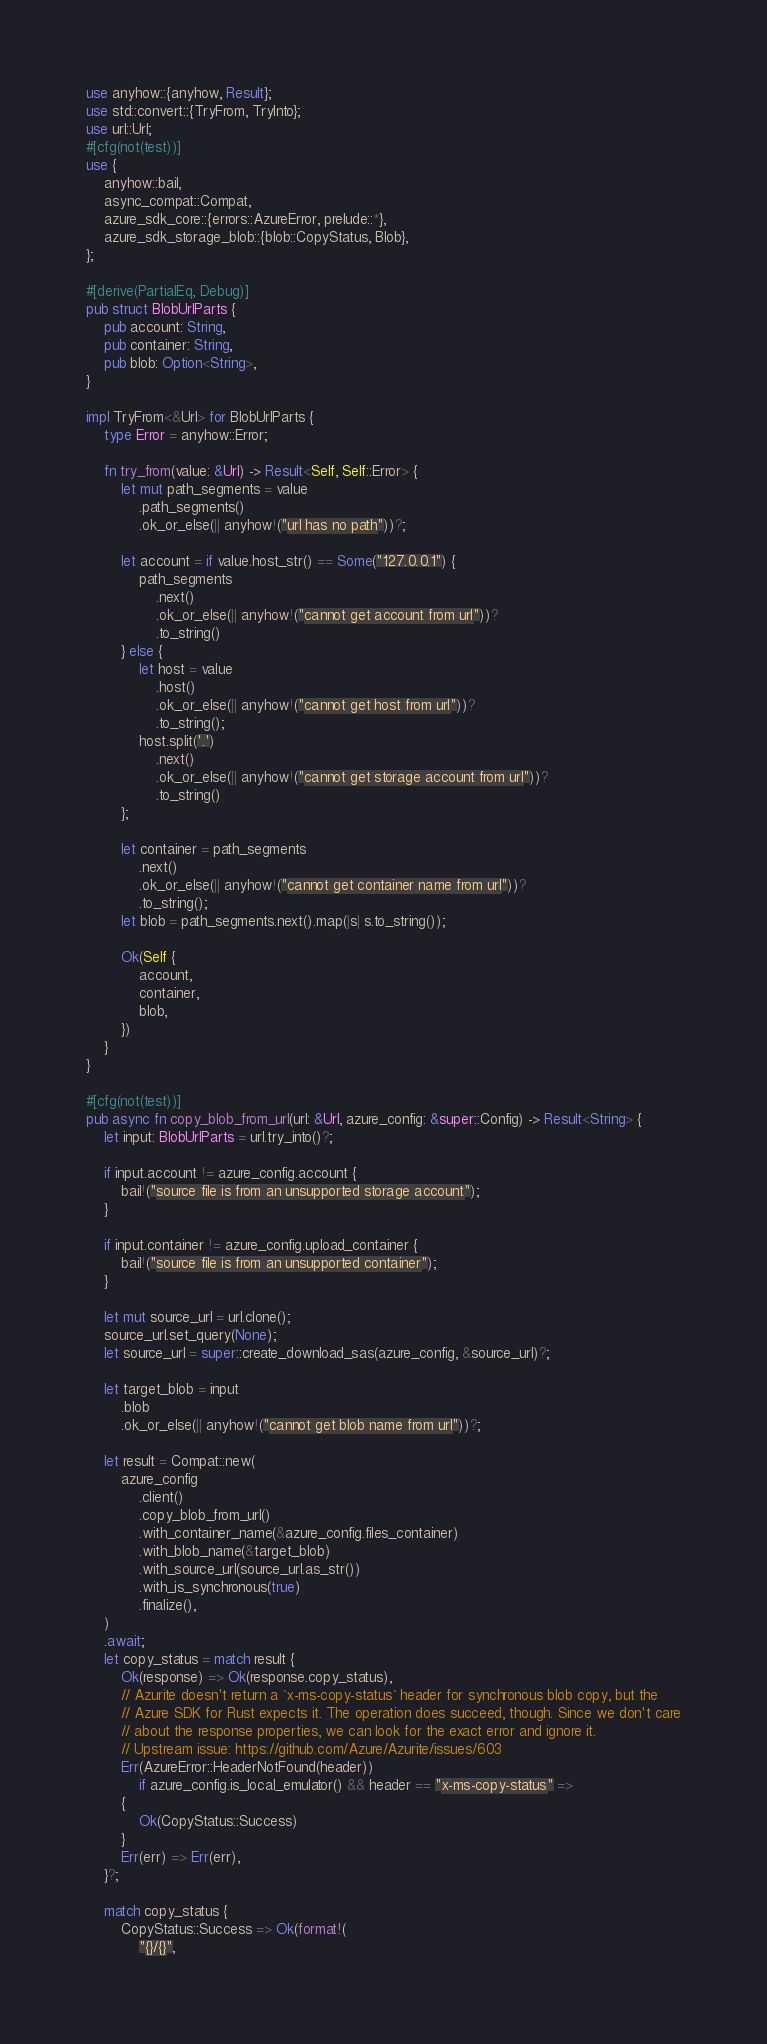Convert code to text. <code><loc_0><loc_0><loc_500><loc_500><_Rust_>use anyhow::{anyhow, Result};
use std::convert::{TryFrom, TryInto};
use url::Url;
#[cfg(not(test))]
use {
    anyhow::bail,
    async_compat::Compat,
    azure_sdk_core::{errors::AzureError, prelude::*},
    azure_sdk_storage_blob::{blob::CopyStatus, Blob},
};

#[derive(PartialEq, Debug)]
pub struct BlobUrlParts {
    pub account: String,
    pub container: String,
    pub blob: Option<String>,
}

impl TryFrom<&Url> for BlobUrlParts {
    type Error = anyhow::Error;

    fn try_from(value: &Url) -> Result<Self, Self::Error> {
        let mut path_segments = value
            .path_segments()
            .ok_or_else(|| anyhow!("url has no path"))?;

        let account = if value.host_str() == Some("127.0.0.1") {
            path_segments
                .next()
                .ok_or_else(|| anyhow!("cannot get account from url"))?
                .to_string()
        } else {
            let host = value
                .host()
                .ok_or_else(|| anyhow!("cannot get host from url"))?
                .to_string();
            host.split('.')
                .next()
                .ok_or_else(|| anyhow!("cannot get storage account from url"))?
                .to_string()
        };

        let container = path_segments
            .next()
            .ok_or_else(|| anyhow!("cannot get container name from url"))?
            .to_string();
        let blob = path_segments.next().map(|s| s.to_string());

        Ok(Self {
            account,
            container,
            blob,
        })
    }
}

#[cfg(not(test))]
pub async fn copy_blob_from_url(url: &Url, azure_config: &super::Config) -> Result<String> {
    let input: BlobUrlParts = url.try_into()?;

    if input.account != azure_config.account {
        bail!("source file is from an unsupported storage account");
    }

    if input.container != azure_config.upload_container {
        bail!("source file is from an unsupported container");
    }

    let mut source_url = url.clone();
    source_url.set_query(None);
    let source_url = super::create_download_sas(azure_config, &source_url)?;

    let target_blob = input
        .blob
        .ok_or_else(|| anyhow!("cannot get blob name from url"))?;

    let result = Compat::new(
        azure_config
            .client()
            .copy_blob_from_url()
            .with_container_name(&azure_config.files_container)
            .with_blob_name(&target_blob)
            .with_source_url(source_url.as_str())
            .with_is_synchronous(true)
            .finalize(),
    )
    .await;
    let copy_status = match result {
        Ok(response) => Ok(response.copy_status),
        // Azurite doesn't return a `x-ms-copy-status` header for synchronous blob copy, but the
        // Azure SDK for Rust expects it. The operation does succeed, though. Since we don't care
        // about the response properties, we can look for the exact error and ignore it.
        // Upstream issue: https://github.com/Azure/Azurite/issues/603
        Err(AzureError::HeaderNotFound(header))
            if azure_config.is_local_emulator() && header == "x-ms-copy-status" =>
        {
            Ok(CopyStatus::Success)
        }
        Err(err) => Err(err),
    }?;

    match copy_status {
        CopyStatus::Success => Ok(format!(
            "{}/{}",</code> 